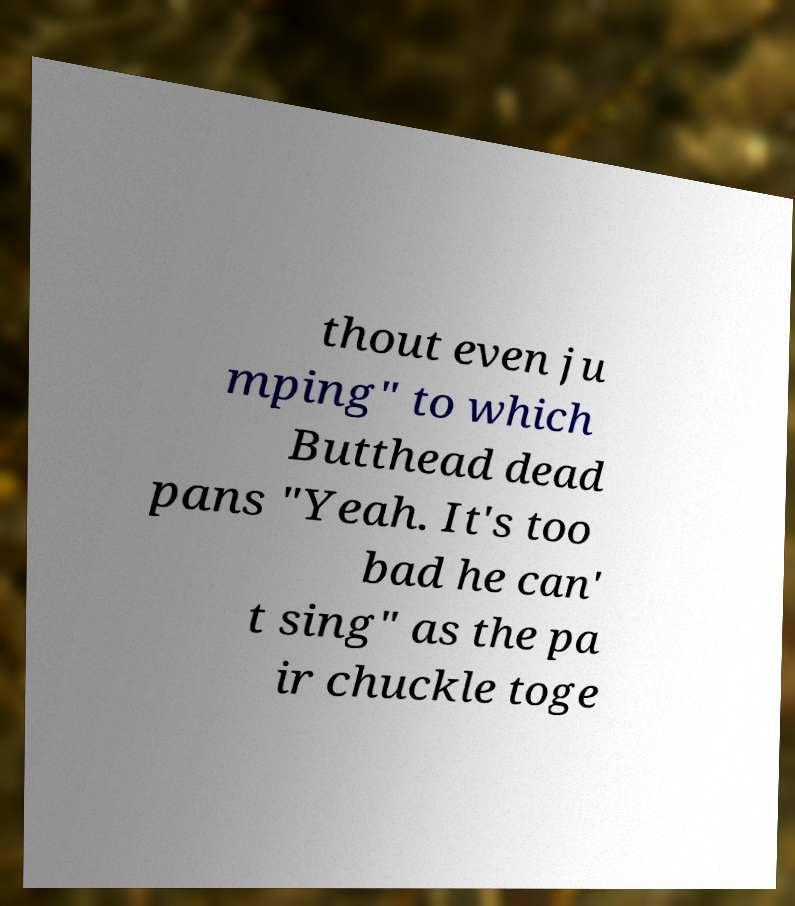I need the written content from this picture converted into text. Can you do that? thout even ju mping" to which Butthead dead pans "Yeah. It's too bad he can' t sing" as the pa ir chuckle toge 